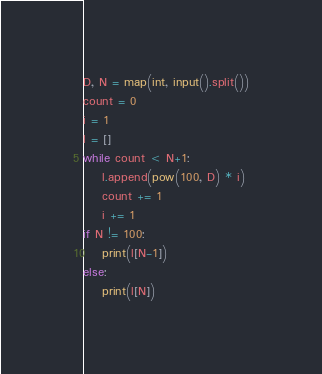<code> <loc_0><loc_0><loc_500><loc_500><_Python_>D, N = map(int, input().split())
count = 0
i = 1
l = []
while count < N+1:
    l.append(pow(100, D) * i)
    count += 1
    i += 1
if N != 100:
    print(l[N-1])
else:
    print(l[N])</code> 